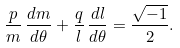<formula> <loc_0><loc_0><loc_500><loc_500>\frac { p } { m } \, \frac { d m } { d \theta } + \frac { q } { l } \, \frac { d l } { d \theta } = \frac { \sqrt { - 1 } } { 2 } .</formula> 